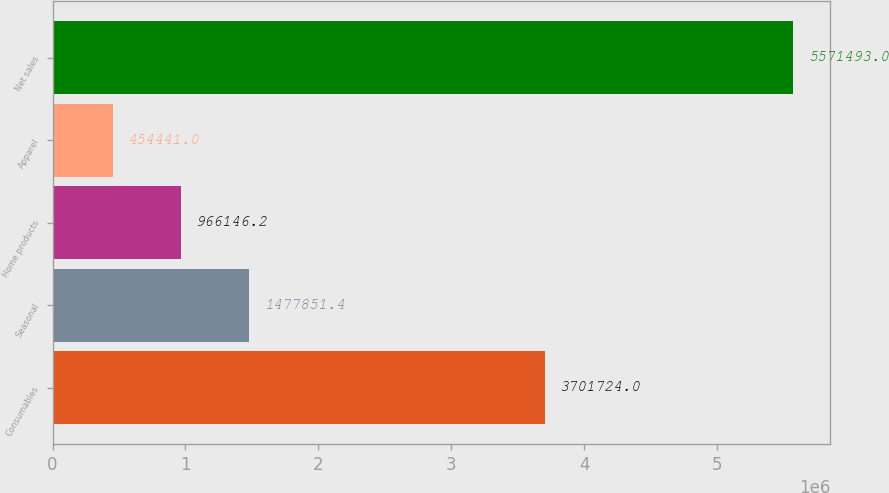Convert chart. <chart><loc_0><loc_0><loc_500><loc_500><bar_chart><fcel>Consumables<fcel>Seasonal<fcel>Home products<fcel>Apparel<fcel>Net sales<nl><fcel>3.70172e+06<fcel>1.47785e+06<fcel>966146<fcel>454441<fcel>5.57149e+06<nl></chart> 